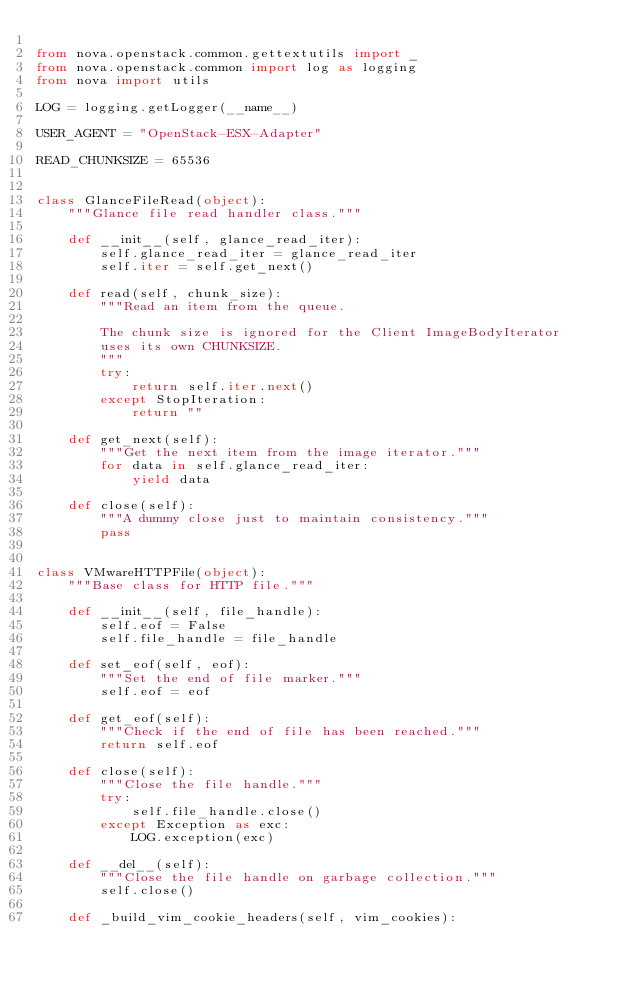Convert code to text. <code><loc_0><loc_0><loc_500><loc_500><_Python_>
from nova.openstack.common.gettextutils import _
from nova.openstack.common import log as logging
from nova import utils

LOG = logging.getLogger(__name__)

USER_AGENT = "OpenStack-ESX-Adapter"

READ_CHUNKSIZE = 65536


class GlanceFileRead(object):
    """Glance file read handler class."""

    def __init__(self, glance_read_iter):
        self.glance_read_iter = glance_read_iter
        self.iter = self.get_next()

    def read(self, chunk_size):
        """Read an item from the queue.

        The chunk size is ignored for the Client ImageBodyIterator
        uses its own CHUNKSIZE.
        """
        try:
            return self.iter.next()
        except StopIteration:
            return ""

    def get_next(self):
        """Get the next item from the image iterator."""
        for data in self.glance_read_iter:
            yield data

    def close(self):
        """A dummy close just to maintain consistency."""
        pass


class VMwareHTTPFile(object):
    """Base class for HTTP file."""

    def __init__(self, file_handle):
        self.eof = False
        self.file_handle = file_handle

    def set_eof(self, eof):
        """Set the end of file marker."""
        self.eof = eof

    def get_eof(self):
        """Check if the end of file has been reached."""
        return self.eof

    def close(self):
        """Close the file handle."""
        try:
            self.file_handle.close()
        except Exception as exc:
            LOG.exception(exc)

    def __del__(self):
        """Close the file handle on garbage collection."""
        self.close()

    def _build_vim_cookie_headers(self, vim_cookies):</code> 